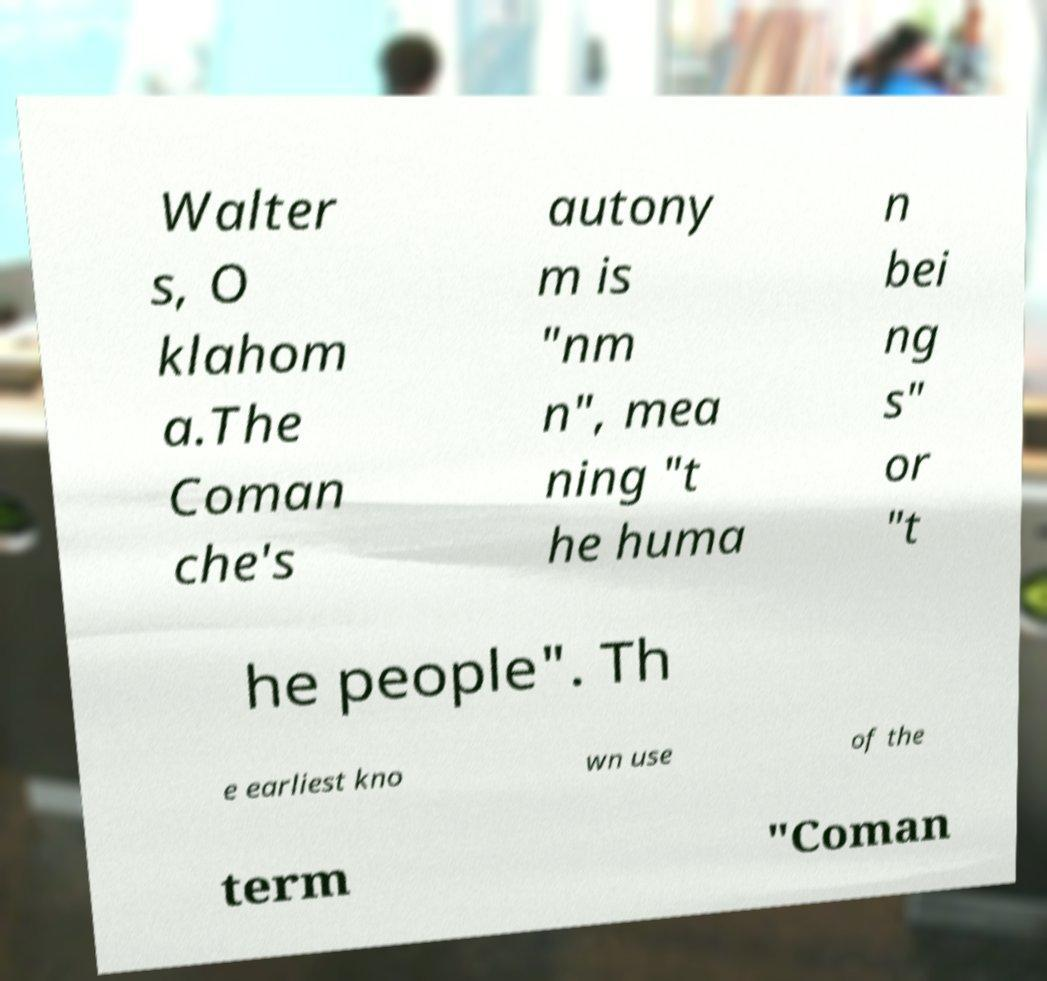Could you assist in decoding the text presented in this image and type it out clearly? Walter s, O klahom a.The Coman che's autony m is "nm n", mea ning "t he huma n bei ng s" or "t he people". Th e earliest kno wn use of the term "Coman 